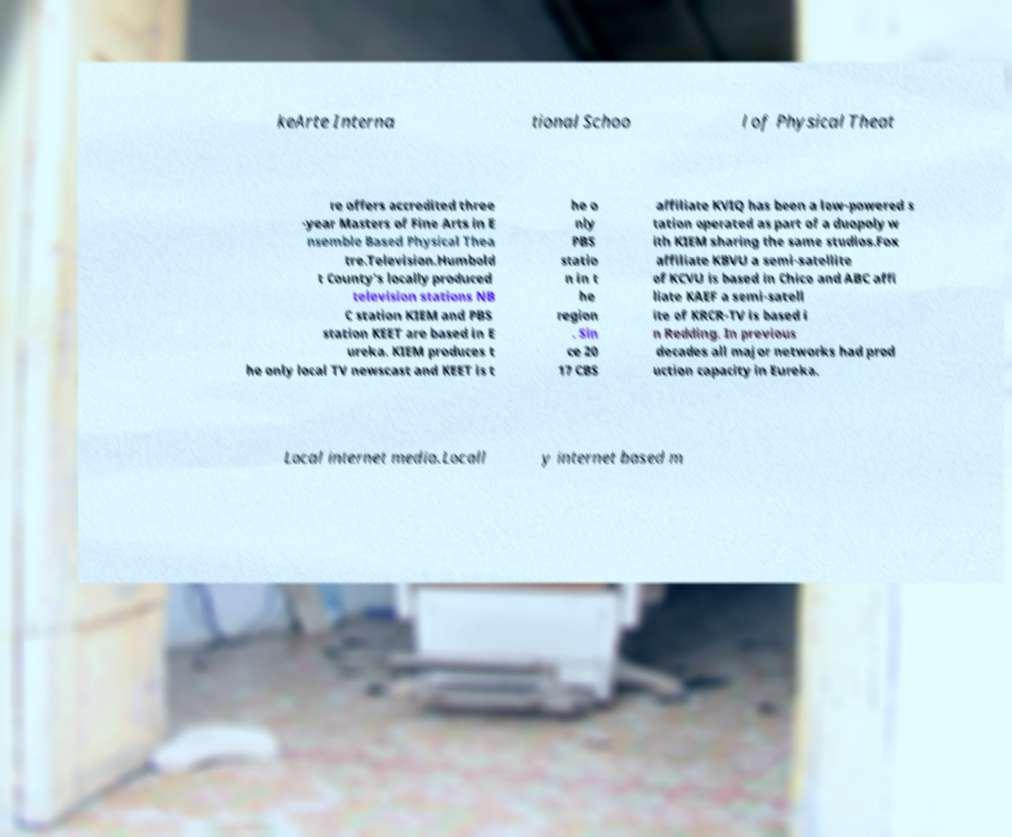I need the written content from this picture converted into text. Can you do that? keArte Interna tional Schoo l of Physical Theat re offers accredited three -year Masters of Fine Arts in E nsemble Based Physical Thea tre.Television.Humbold t County's locally produced television stations NB C station KIEM and PBS station KEET are based in E ureka. KIEM produces t he only local TV newscast and KEET is t he o nly PBS statio n in t he region . Sin ce 20 17 CBS affiliate KVIQ has been a low-powered s tation operated as part of a duopoly w ith KIEM sharing the same studios.Fox affiliate KBVU a semi-satellite of KCVU is based in Chico and ABC affi liate KAEF a semi-satell ite of KRCR-TV is based i n Redding. In previous decades all major networks had prod uction capacity in Eureka. Local internet media.Locall y internet based m 